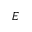<formula> <loc_0><loc_0><loc_500><loc_500>E</formula> 